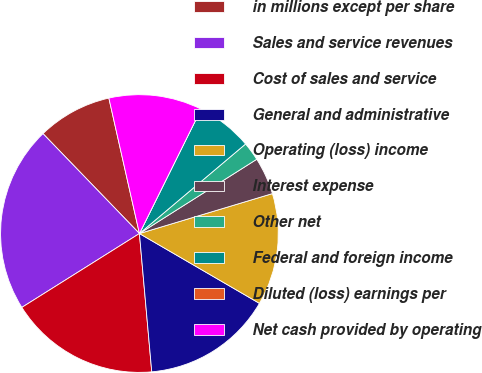Convert chart to OTSL. <chart><loc_0><loc_0><loc_500><loc_500><pie_chart><fcel>in millions except per share<fcel>Sales and service revenues<fcel>Cost of sales and service<fcel>General and administrative<fcel>Operating (loss) income<fcel>Interest expense<fcel>Other net<fcel>Federal and foreign income<fcel>Diluted (loss) earnings per<fcel>Net cash provided by operating<nl><fcel>8.69%<fcel>21.71%<fcel>17.49%<fcel>15.2%<fcel>13.03%<fcel>4.34%<fcel>2.17%<fcel>6.52%<fcel>0.0%<fcel>10.86%<nl></chart> 